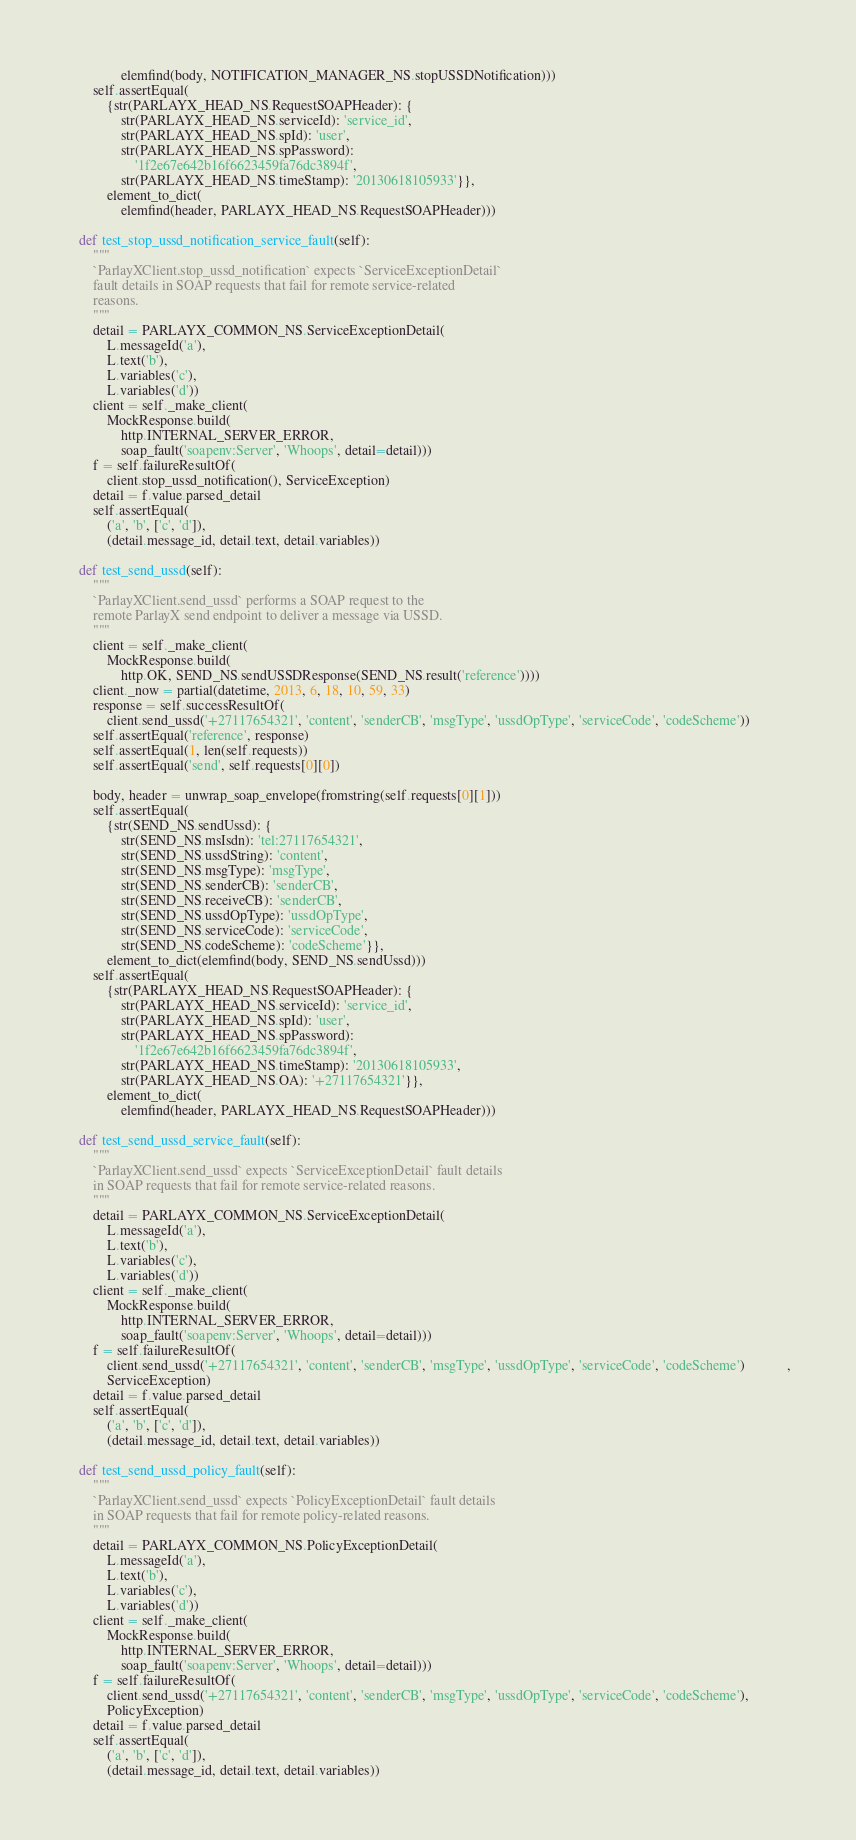Convert code to text. <code><loc_0><loc_0><loc_500><loc_500><_Python_>                elemfind(body, NOTIFICATION_MANAGER_NS.stopUSSDNotification)))
        self.assertEqual(
            {str(PARLAYX_HEAD_NS.RequestSOAPHeader): {
                str(PARLAYX_HEAD_NS.serviceId): 'service_id',
                str(PARLAYX_HEAD_NS.spId): 'user',
                str(PARLAYX_HEAD_NS.spPassword):
                    '1f2e67e642b16f6623459fa76dc3894f',
                str(PARLAYX_HEAD_NS.timeStamp): '20130618105933'}},
            element_to_dict(
                elemfind(header, PARLAYX_HEAD_NS.RequestSOAPHeader)))

    def test_stop_ussd_notification_service_fault(self):
        """
        `ParlayXClient.stop_ussd_notification` expects `ServiceExceptionDetail`
        fault details in SOAP requests that fail for remote service-related
        reasons.
        """
        detail = PARLAYX_COMMON_NS.ServiceExceptionDetail(
            L.messageId('a'),
            L.text('b'),
            L.variables('c'),
            L.variables('d'))
        client = self._make_client(
            MockResponse.build(
                http.INTERNAL_SERVER_ERROR,
                soap_fault('soapenv:Server', 'Whoops', detail=detail)))
        f = self.failureResultOf(
            client.stop_ussd_notification(), ServiceException)
        detail = f.value.parsed_detail
        self.assertEqual(
            ('a', 'b', ['c', 'd']),
            (detail.message_id, detail.text, detail.variables))

    def test_send_ussd(self):
        """
        `ParlayXClient.send_ussd` performs a SOAP request to the
        remote ParlayX send endpoint to deliver a message via USSD.
        """
        client = self._make_client(
            MockResponse.build(
                http.OK, SEND_NS.sendUSSDResponse(SEND_NS.result('reference'))))
        client._now = partial(datetime, 2013, 6, 18, 10, 59, 33)
        response = self.successResultOf(
            client.send_ussd('+27117654321', 'content', 'senderCB', 'msgType', 'ussdOpType', 'serviceCode', 'codeScheme'))
        self.assertEqual('reference', response)
        self.assertEqual(1, len(self.requests))
        self.assertEqual('send', self.requests[0][0])

        body, header = unwrap_soap_envelope(fromstring(self.requests[0][1]))
        self.assertEqual(
            {str(SEND_NS.sendUssd): {
                str(SEND_NS.msIsdn): 'tel:27117654321',
                str(SEND_NS.ussdString): 'content',
                str(SEND_NS.msgType): 'msgType',
                str(SEND_NS.senderCB): 'senderCB',
                str(SEND_NS.receiveCB): 'senderCB',
                str(SEND_NS.ussdOpType): 'ussdOpType',
                str(SEND_NS.serviceCode): 'serviceCode',
                str(SEND_NS.codeScheme): 'codeScheme'}},
            element_to_dict(elemfind(body, SEND_NS.sendUssd)))
        self.assertEqual(
            {str(PARLAYX_HEAD_NS.RequestSOAPHeader): {
                str(PARLAYX_HEAD_NS.serviceId): 'service_id',
                str(PARLAYX_HEAD_NS.spId): 'user',
                str(PARLAYX_HEAD_NS.spPassword):
                    '1f2e67e642b16f6623459fa76dc3894f',
                str(PARLAYX_HEAD_NS.timeStamp): '20130618105933',
                str(PARLAYX_HEAD_NS.OA): '+27117654321'}},
            element_to_dict(
                elemfind(header, PARLAYX_HEAD_NS.RequestSOAPHeader)))

    def test_send_ussd_service_fault(self):
        """
        `ParlayXClient.send_ussd` expects `ServiceExceptionDetail` fault details
        in SOAP requests that fail for remote service-related reasons.
        """
        detail = PARLAYX_COMMON_NS.ServiceExceptionDetail(
            L.messageId('a'),
            L.text('b'),
            L.variables('c'),
            L.variables('d'))
        client = self._make_client(
            MockResponse.build(
                http.INTERNAL_SERVER_ERROR,
                soap_fault('soapenv:Server', 'Whoops', detail=detail)))
        f = self.failureResultOf(
            client.send_ussd('+27117654321', 'content', 'senderCB', 'msgType', 'ussdOpType', 'serviceCode', 'codeScheme')            ,
            ServiceException)
        detail = f.value.parsed_detail
        self.assertEqual(
            ('a', 'b', ['c', 'd']),
            (detail.message_id, detail.text, detail.variables))

    def test_send_ussd_policy_fault(self):
        """
        `ParlayXClient.send_ussd` expects `PolicyExceptionDetail` fault details
        in SOAP requests that fail for remote policy-related reasons.
        """
        detail = PARLAYX_COMMON_NS.PolicyExceptionDetail(
            L.messageId('a'),
            L.text('b'),
            L.variables('c'),
            L.variables('d'))
        client = self._make_client(
            MockResponse.build(
                http.INTERNAL_SERVER_ERROR,
                soap_fault('soapenv:Server', 'Whoops', detail=detail)))
        f = self.failureResultOf(
            client.send_ussd('+27117654321', 'content', 'senderCB', 'msgType', 'ussdOpType', 'serviceCode', 'codeScheme'),
            PolicyException)
        detail = f.value.parsed_detail
        self.assertEqual(
            ('a', 'b', ['c', 'd']),
            (detail.message_id, detail.text, detail.variables))
</code> 